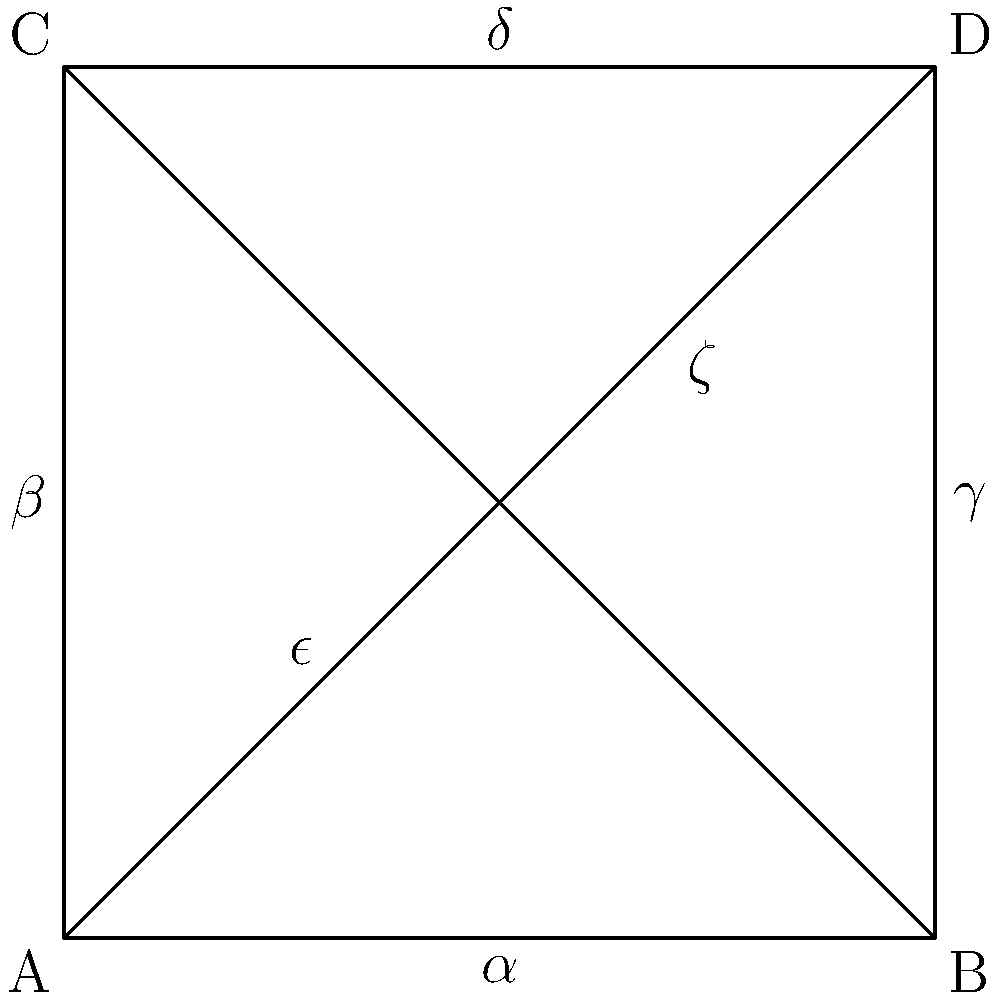Consider a space representing interconnected film studio lots, as shown in the diagram. Each vertex (A, B, C, D) represents a studio lot, and the edges represent paths between them. Calculate the rank of the fundamental group of this space, assuming it's homotopy equivalent to a graph. How might this relate to the interconnectedness of different film genres in a crime comedy enthusiast's perspective? To solve this problem, we'll follow these steps:

1) First, recall that for a graph, the fundamental group is a free group, and its rank is equal to the number of edges we need to remove to obtain a spanning tree.

2) In this diagram, we have:
   - 4 vertices (A, B, C, D)
   - 6 edges ($\alpha$, $\beta$, $\gamma$, $\delta$, $\epsilon$, $\zeta$)

3) To create a spanning tree, we need to keep 3 edges (one less than the number of vertices) and remove the rest.

4) So, we need to remove 6 - 3 = 3 edges to obtain a spanning tree.

5) Therefore, the rank of the fundamental group is 3.

6) In terms of film genres and crime comedies:
   - Each vertex could represent a different genre (e.g., A: Crime, B: Comedy, C: Classic, D: Modern)
   - The edges represent how these genres interconnect in films
   - The rank 3 suggests there are three independent ways to combine these genres, which could represent:
     a) Crime + Comedy (traditional crime comedy)
     b) Classic + Modern (mixing classic structure with modern elements)
     c) An unexpected combination (e.g., Classic Crime Comedy with Modern elements)

This structure allows for various combinations and paths between genres, much like how a picky movie lover might appreciate the nuanced connections between different film styles in crime comedies.
Answer: Rank 3 